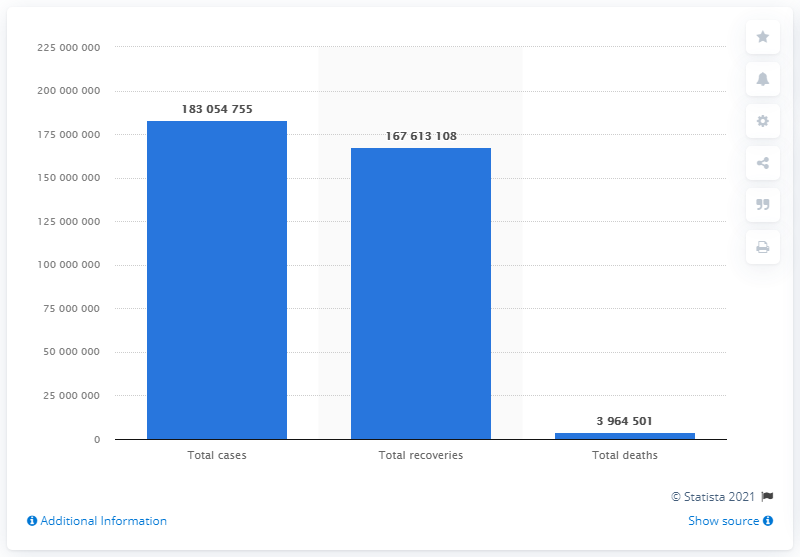Draw attention to some important aspects in this diagram. As of [date], a total of 167,613,108 people have recovered from COVID-19. 